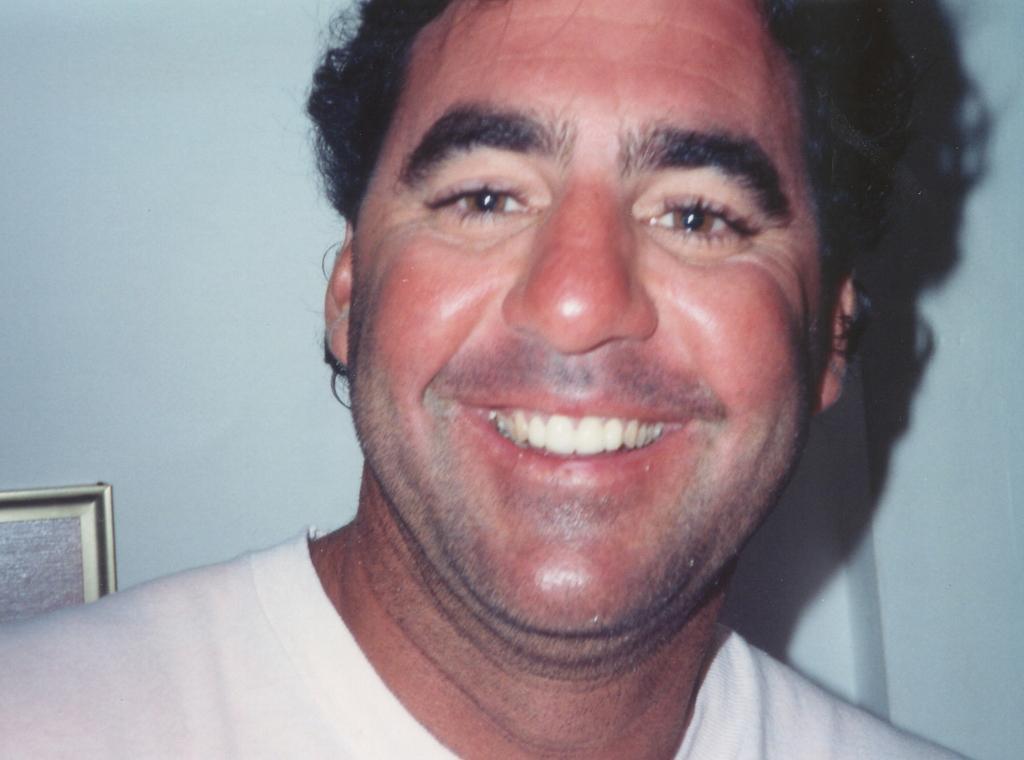Can you describe this image briefly? In this image we can see a person with smiling face. In the background, we can see the wall with a photo frame. 